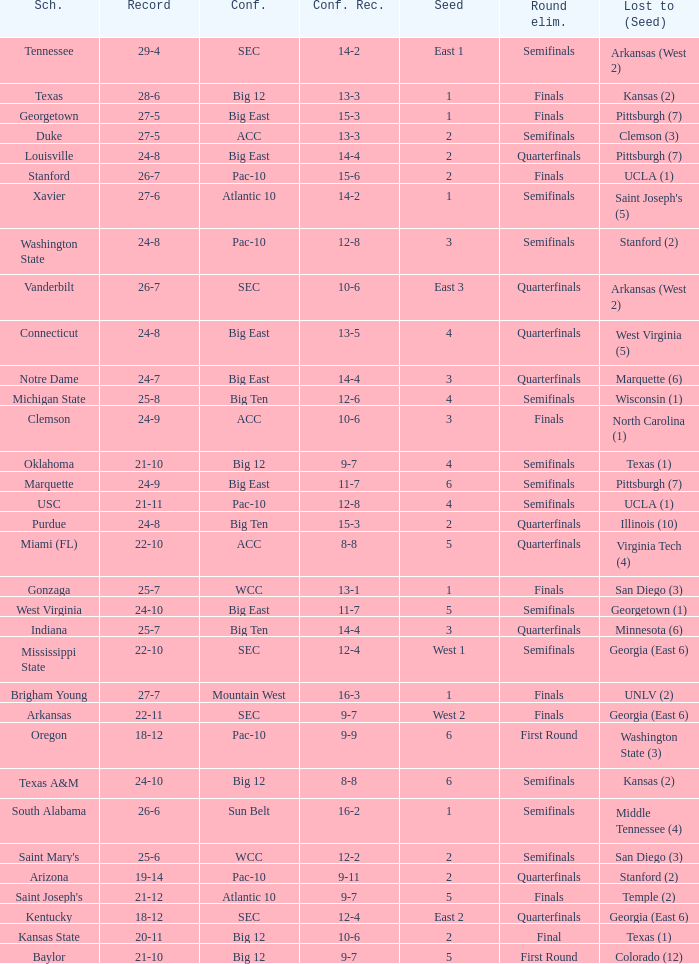Name the round eliminated where conference record is 12-6 Semifinals. 